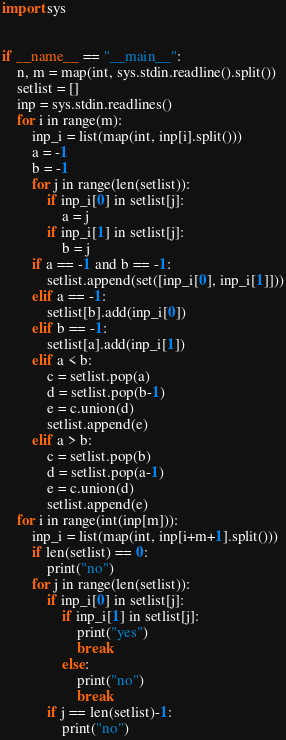Convert code to text. <code><loc_0><loc_0><loc_500><loc_500><_Python_>import sys


if __name__ == "__main__":
    n, m = map(int, sys.stdin.readline().split())
    setlist = []
    inp = sys.stdin.readlines()
    for i in range(m):
        inp_i = list(map(int, inp[i].split()))
        a = -1
        b = -1
        for j in range(len(setlist)):
            if inp_i[0] in setlist[j]:
                a = j
            if inp_i[1] in setlist[j]:
                b = j
        if a == -1 and b == -1:
            setlist.append(set([inp_i[0], inp_i[1]]))
        elif a == -1:
            setlist[b].add(inp_i[0])
        elif b == -1:
            setlist[a].add(inp_i[1])
        elif a < b:
            c = setlist.pop(a)
            d = setlist.pop(b-1)
            e = c.union(d)
            setlist.append(e)
        elif a > b:
            c = setlist.pop(b)
            d = setlist.pop(a-1)
            e = c.union(d)
            setlist.append(e)
    for i in range(int(inp[m])):
        inp_i = list(map(int, inp[i+m+1].split()))
        if len(setlist) == 0:
            print("no")
        for j in range(len(setlist)):
            if inp_i[0] in setlist[j]:
                if inp_i[1] in setlist[j]:
                    print("yes")
                    break
                else:
                    print("no")
                    break
            if j == len(setlist)-1:
                print("no")</code> 